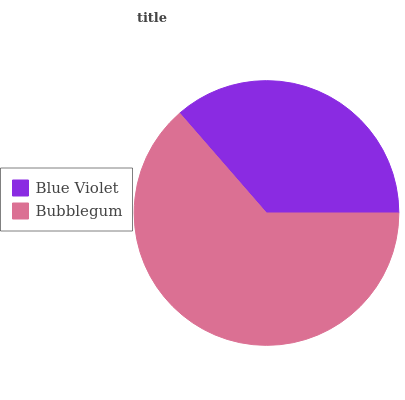Is Blue Violet the minimum?
Answer yes or no. Yes. Is Bubblegum the maximum?
Answer yes or no. Yes. Is Bubblegum the minimum?
Answer yes or no. No. Is Bubblegum greater than Blue Violet?
Answer yes or no. Yes. Is Blue Violet less than Bubblegum?
Answer yes or no. Yes. Is Blue Violet greater than Bubblegum?
Answer yes or no. No. Is Bubblegum less than Blue Violet?
Answer yes or no. No. Is Bubblegum the high median?
Answer yes or no. Yes. Is Blue Violet the low median?
Answer yes or no. Yes. Is Blue Violet the high median?
Answer yes or no. No. Is Bubblegum the low median?
Answer yes or no. No. 